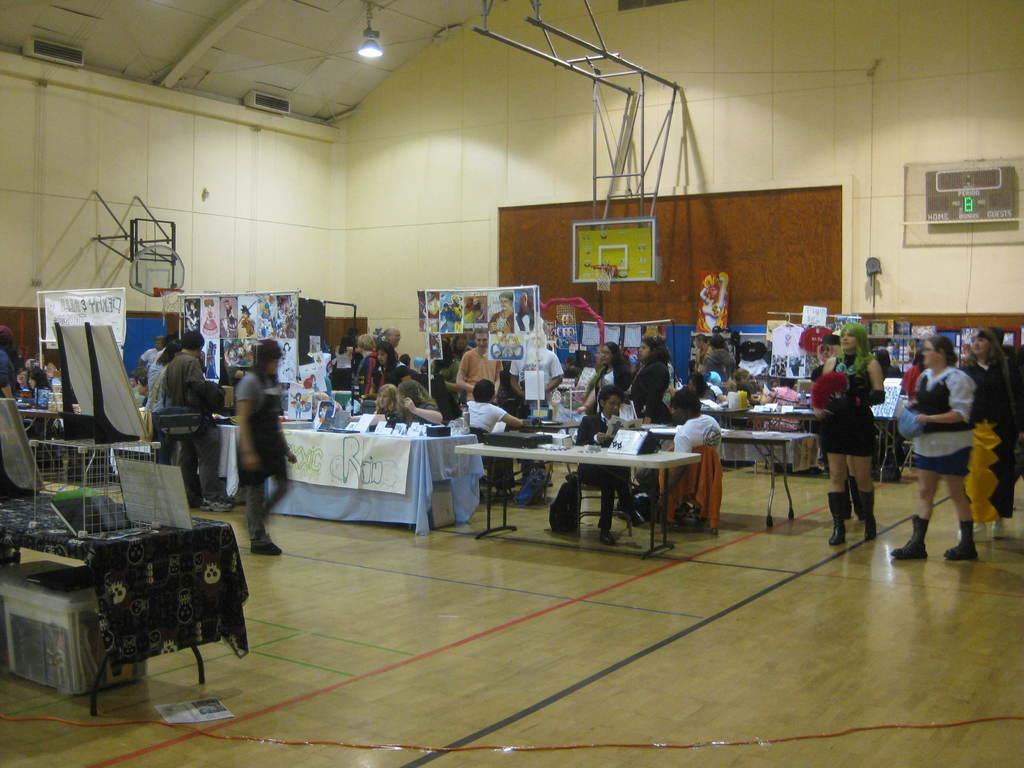Could you give a brief overview of what you see in this image? This is the picture of a place where we have some chairs and tables and some things placed on the tables and there are some people sitting on the chats and some standing there is also a notice board on which there is a thing placed on it 